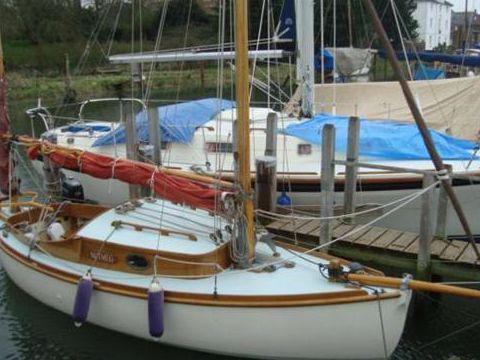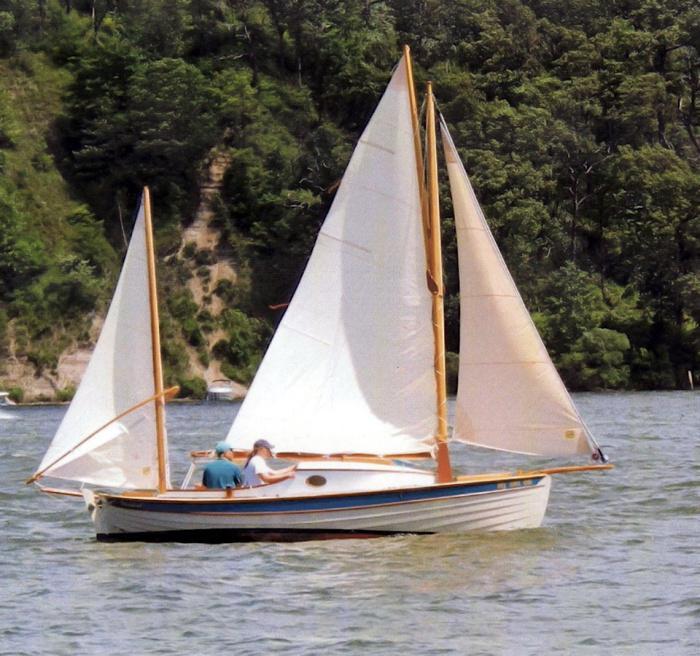The first image is the image on the left, the second image is the image on the right. Examine the images to the left and right. Is the description "The boat in the right image has its sails up." accurate? Answer yes or no. Yes. 